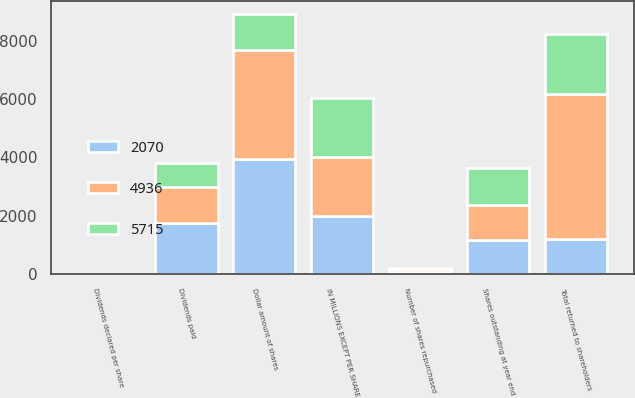Convert chart. <chart><loc_0><loc_0><loc_500><loc_500><stacked_bar_chart><ecel><fcel>IN MILLIONS EXCEPT PER SHARE<fcel>Number of shares repurchased<fcel>Shares outstanding at year end<fcel>Dividends declared per share<fcel>Dollar amount of shares<fcel>Dividends paid<fcel>Total returned to shareholders<nl><fcel>2070<fcel>2007<fcel>77.1<fcel>1165<fcel>1.5<fcel>3949<fcel>1766<fcel>1222.5<nl><fcel>4936<fcel>2006<fcel>98.4<fcel>1204<fcel>1<fcel>3719<fcel>1217<fcel>4936<nl><fcel>5715<fcel>2005<fcel>39.5<fcel>1263<fcel>0.67<fcel>1228<fcel>842<fcel>2070<nl></chart> 